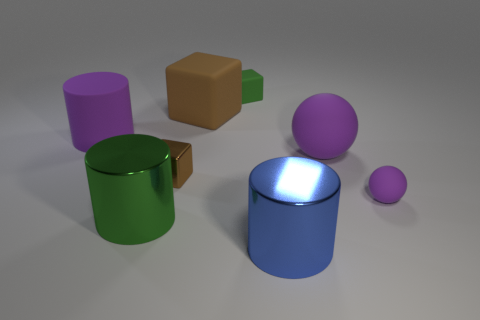Add 2 big brown rubber blocks. How many objects exist? 10 Subtract all metallic cylinders. How many cylinders are left? 1 Subtract all spheres. How many objects are left? 6 Subtract all big green spheres. Subtract all big blocks. How many objects are left? 7 Add 2 rubber objects. How many rubber objects are left? 7 Add 3 tiny purple matte spheres. How many tiny purple matte spheres exist? 4 Subtract 0 purple cubes. How many objects are left? 8 